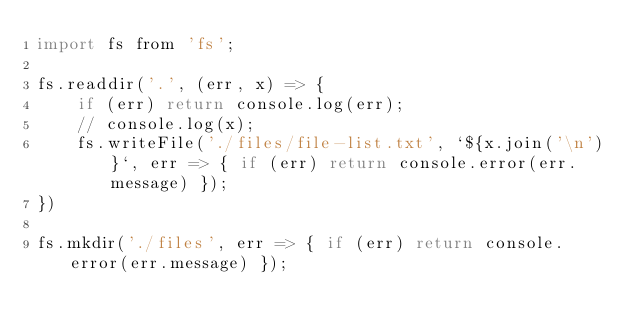Convert code to text. <code><loc_0><loc_0><loc_500><loc_500><_JavaScript_>import fs from 'fs';

fs.readdir('.', (err, x) => {
    if (err) return console.log(err);
    // console.log(x);
    fs.writeFile('./files/file-list.txt', `${x.join('\n')}`, err => { if (err) return console.error(err.message) });
})

fs.mkdir('./files', err => { if (err) return console.error(err.message) });</code> 